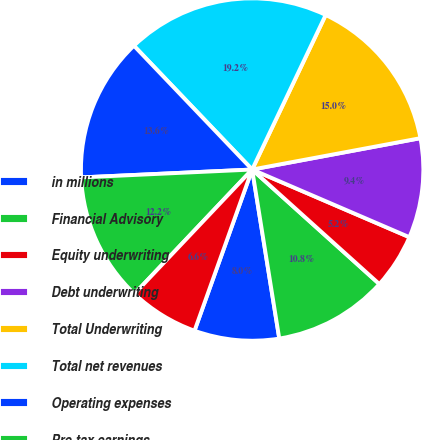Convert chart. <chart><loc_0><loc_0><loc_500><loc_500><pie_chart><fcel>in millions<fcel>Financial Advisory<fcel>Equity underwriting<fcel>Debt underwriting<fcel>Total Underwriting<fcel>Total net revenues<fcel>Operating expenses<fcel>Pre-tax earnings<fcel>Segment assets<nl><fcel>8.0%<fcel>10.8%<fcel>5.2%<fcel>9.4%<fcel>15.0%<fcel>19.2%<fcel>13.6%<fcel>12.2%<fcel>6.6%<nl></chart> 